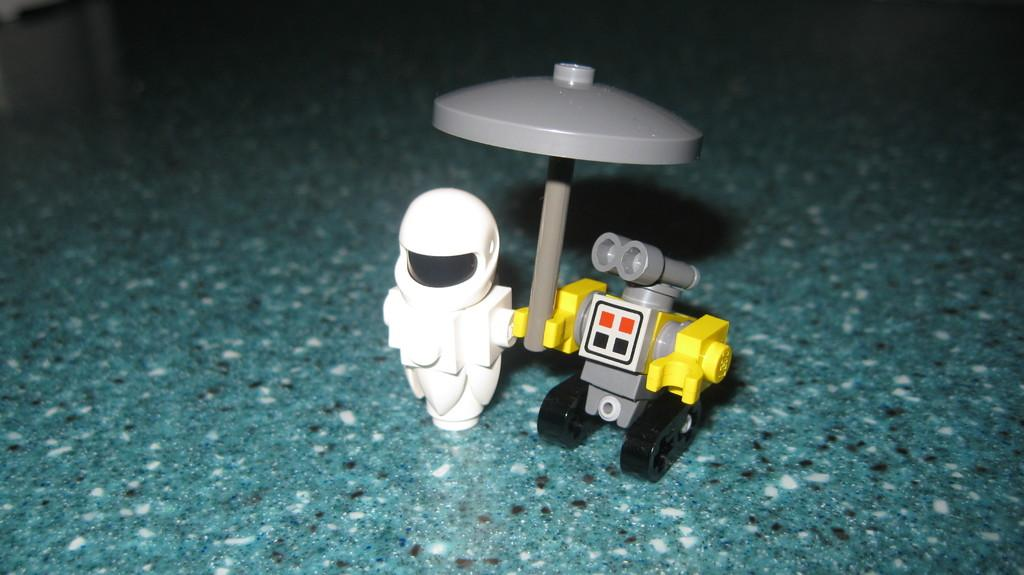What objects are present in the image? There are toys in the image. What is the color of the surface on which the toys are placed? The toys are on a green surface. What colors can be seen on the toys? The toys are in white, yellow, and gray colors. How many legs does the tramp have in the image? There is no tramp present in the image, so it is not possible to determine the number of legs it might have. 